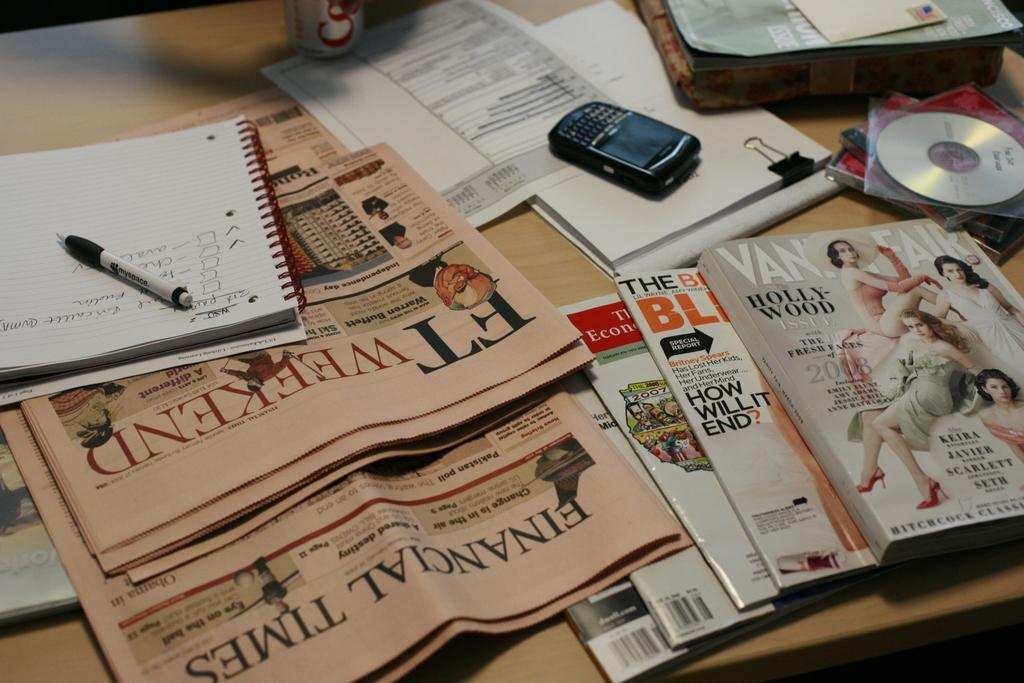Provide a one-sentence caption for the provided image. A table covered with newspapers and magazine including vanity fair. 